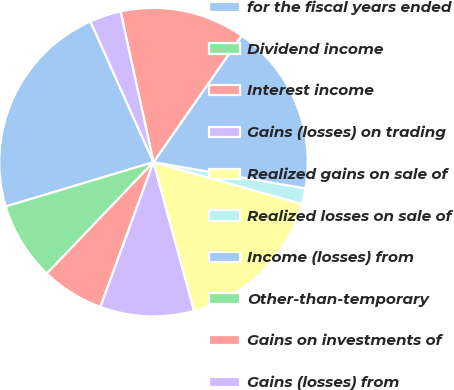Convert chart. <chart><loc_0><loc_0><loc_500><loc_500><pie_chart><fcel>for the fiscal years ended<fcel>Dividend income<fcel>Interest income<fcel>Gains (losses) on trading<fcel>Realized gains on sale of<fcel>Realized losses on sale of<fcel>Income (losses) from<fcel>Other-than-temporary<fcel>Gains on investments of<fcel>Gains (losses) from<nl><fcel>22.94%<fcel>8.2%<fcel>6.56%<fcel>9.84%<fcel>16.39%<fcel>1.64%<fcel>18.03%<fcel>0.0%<fcel>13.11%<fcel>3.28%<nl></chart> 